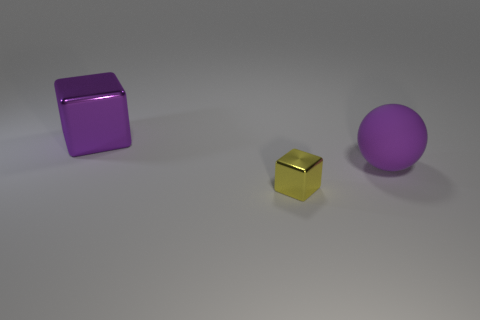Add 1 large purple spheres. How many objects exist? 4 Subtract all cubes. How many objects are left? 1 Subtract all purple rubber cylinders. Subtract all large purple metal cubes. How many objects are left? 2 Add 3 yellow metallic things. How many yellow metallic things are left? 4 Add 2 small gray balls. How many small gray balls exist? 2 Subtract 1 purple blocks. How many objects are left? 2 